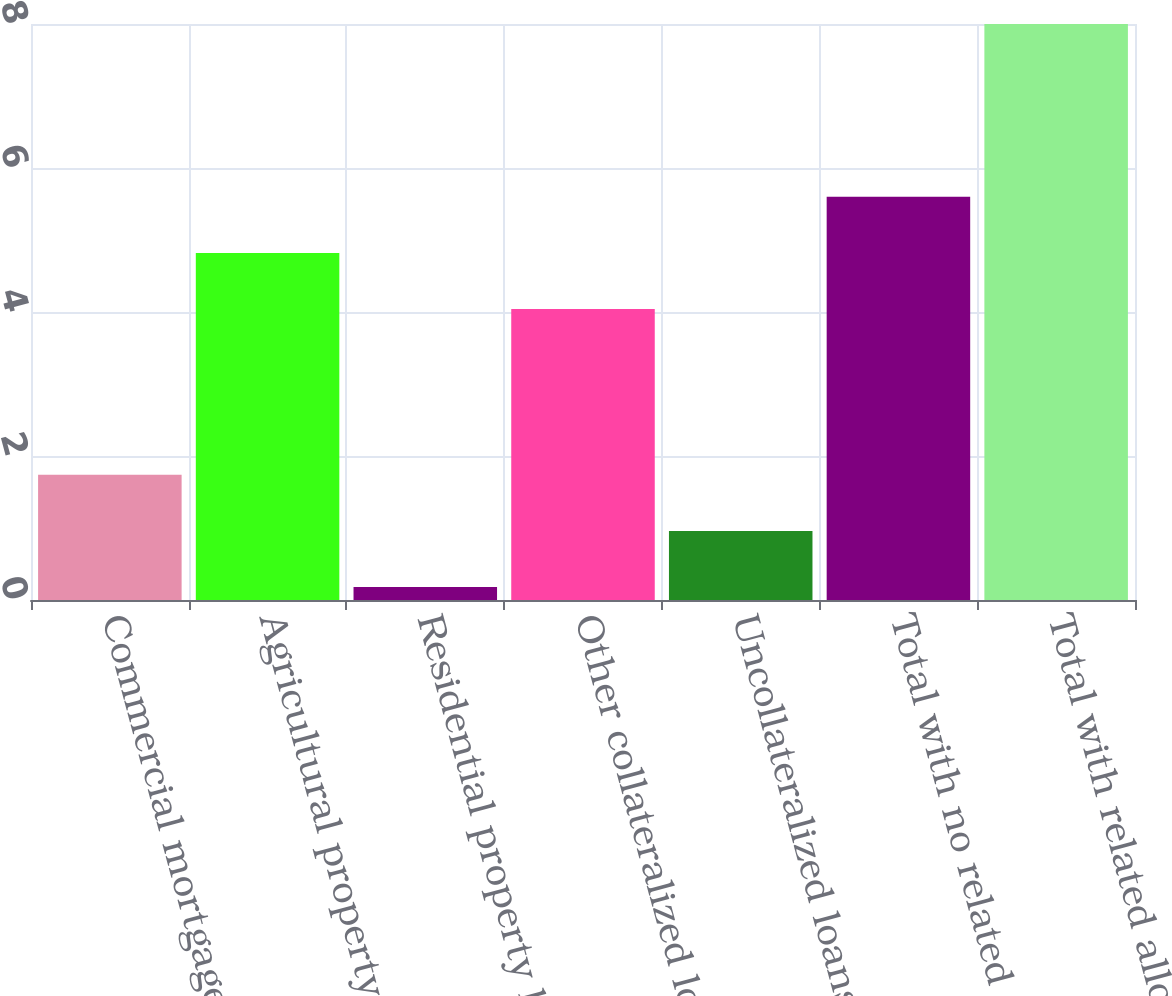<chart> <loc_0><loc_0><loc_500><loc_500><bar_chart><fcel>Commercial mortgage loans<fcel>Agricultural property loans<fcel>Residential property loans<fcel>Other collateralized loans<fcel>Uncollateralized loans<fcel>Total with no related<fcel>Total with related allowance<nl><fcel>1.74<fcel>4.82<fcel>0.18<fcel>4.04<fcel>0.96<fcel>5.6<fcel>8<nl></chart> 